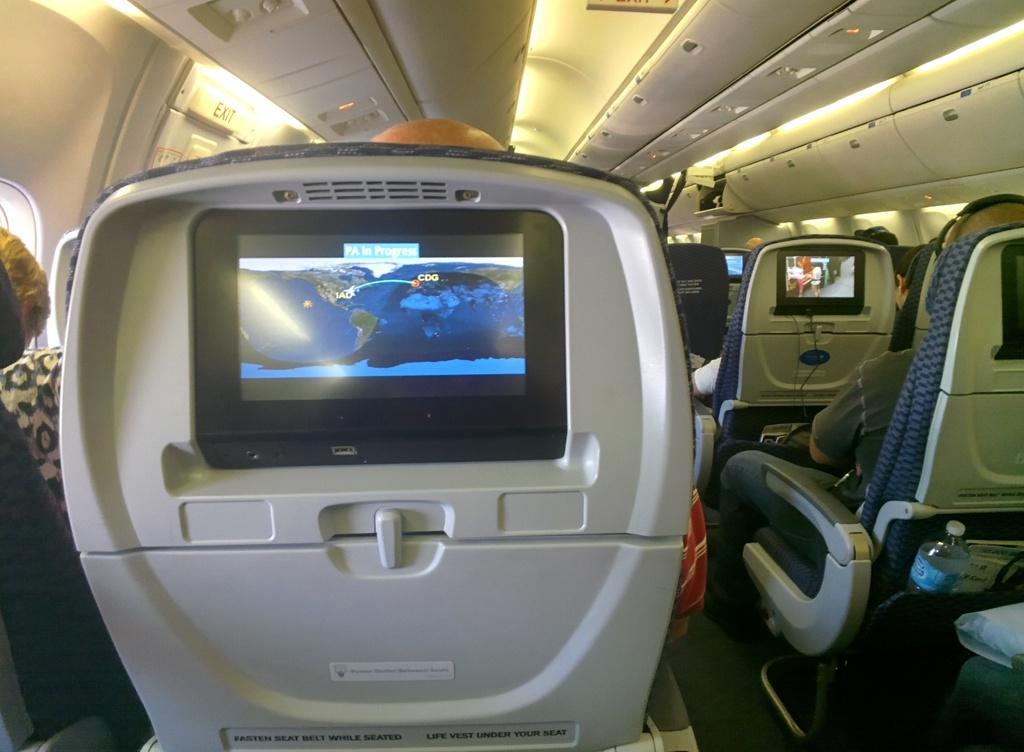In one or two sentences, can you explain what this image depicts? In this image I can see the interior of an aeroplane in which I can see the ceiling, few lights to the ceiling, few chairs, few persons sitting on chairs and screens attached to the chairs. 